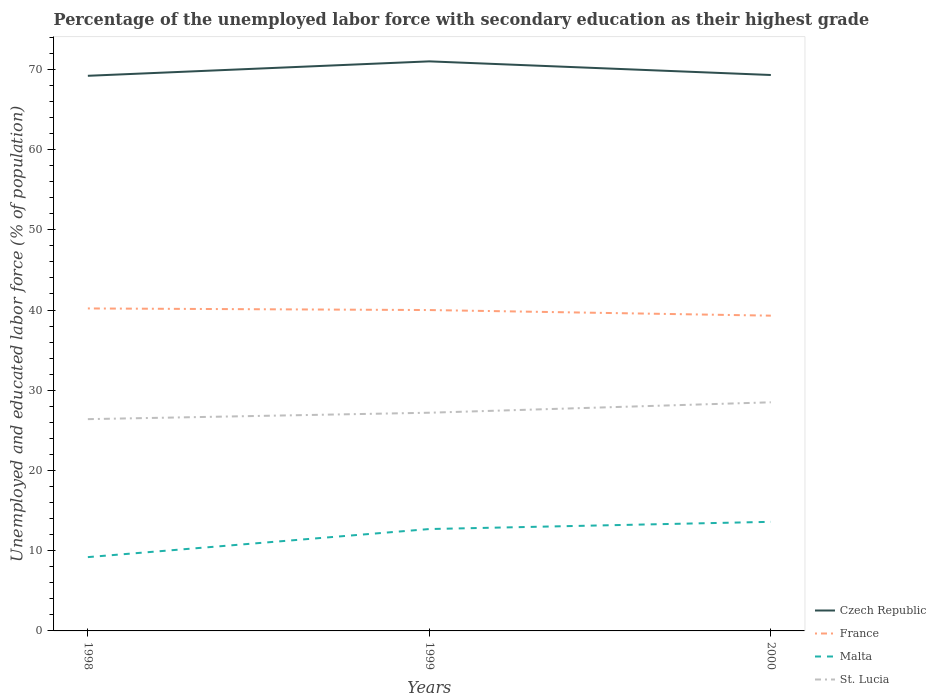Across all years, what is the maximum percentage of the unemployed labor force with secondary education in Czech Republic?
Your answer should be compact. 69.2. In which year was the percentage of the unemployed labor force with secondary education in Czech Republic maximum?
Give a very brief answer. 1998. What is the total percentage of the unemployed labor force with secondary education in Malta in the graph?
Make the answer very short. -0.9. What is the difference between the highest and the second highest percentage of the unemployed labor force with secondary education in France?
Offer a terse response. 0.9. What is the difference between two consecutive major ticks on the Y-axis?
Offer a terse response. 10. Are the values on the major ticks of Y-axis written in scientific E-notation?
Provide a succinct answer. No. Does the graph contain any zero values?
Ensure brevity in your answer.  No. How many legend labels are there?
Your response must be concise. 4. What is the title of the graph?
Provide a short and direct response. Percentage of the unemployed labor force with secondary education as their highest grade. What is the label or title of the X-axis?
Your answer should be very brief. Years. What is the label or title of the Y-axis?
Ensure brevity in your answer.  Unemployed and educated labor force (% of population). What is the Unemployed and educated labor force (% of population) in Czech Republic in 1998?
Make the answer very short. 69.2. What is the Unemployed and educated labor force (% of population) in France in 1998?
Provide a short and direct response. 40.2. What is the Unemployed and educated labor force (% of population) in Malta in 1998?
Keep it short and to the point. 9.2. What is the Unemployed and educated labor force (% of population) in St. Lucia in 1998?
Offer a very short reply. 26.4. What is the Unemployed and educated labor force (% of population) of Czech Republic in 1999?
Offer a terse response. 71. What is the Unemployed and educated labor force (% of population) of France in 1999?
Provide a short and direct response. 40. What is the Unemployed and educated labor force (% of population) of Malta in 1999?
Ensure brevity in your answer.  12.7. What is the Unemployed and educated labor force (% of population) of St. Lucia in 1999?
Ensure brevity in your answer.  27.2. What is the Unemployed and educated labor force (% of population) of Czech Republic in 2000?
Your answer should be very brief. 69.3. What is the Unemployed and educated labor force (% of population) of France in 2000?
Offer a very short reply. 39.3. What is the Unemployed and educated labor force (% of population) in Malta in 2000?
Your response must be concise. 13.6. What is the Unemployed and educated labor force (% of population) of St. Lucia in 2000?
Offer a very short reply. 28.5. Across all years, what is the maximum Unemployed and educated labor force (% of population) in Czech Republic?
Give a very brief answer. 71. Across all years, what is the maximum Unemployed and educated labor force (% of population) of France?
Offer a very short reply. 40.2. Across all years, what is the maximum Unemployed and educated labor force (% of population) of Malta?
Your response must be concise. 13.6. Across all years, what is the minimum Unemployed and educated labor force (% of population) of Czech Republic?
Offer a terse response. 69.2. Across all years, what is the minimum Unemployed and educated labor force (% of population) of France?
Ensure brevity in your answer.  39.3. Across all years, what is the minimum Unemployed and educated labor force (% of population) of Malta?
Offer a terse response. 9.2. Across all years, what is the minimum Unemployed and educated labor force (% of population) of St. Lucia?
Provide a short and direct response. 26.4. What is the total Unemployed and educated labor force (% of population) in Czech Republic in the graph?
Provide a succinct answer. 209.5. What is the total Unemployed and educated labor force (% of population) in France in the graph?
Provide a short and direct response. 119.5. What is the total Unemployed and educated labor force (% of population) in Malta in the graph?
Ensure brevity in your answer.  35.5. What is the total Unemployed and educated labor force (% of population) of St. Lucia in the graph?
Provide a short and direct response. 82.1. What is the difference between the Unemployed and educated labor force (% of population) in France in 1998 and that in 1999?
Give a very brief answer. 0.2. What is the difference between the Unemployed and educated labor force (% of population) of St. Lucia in 1998 and that in 1999?
Ensure brevity in your answer.  -0.8. What is the difference between the Unemployed and educated labor force (% of population) of France in 1999 and that in 2000?
Offer a very short reply. 0.7. What is the difference between the Unemployed and educated labor force (% of population) of Malta in 1999 and that in 2000?
Offer a very short reply. -0.9. What is the difference between the Unemployed and educated labor force (% of population) in Czech Republic in 1998 and the Unemployed and educated labor force (% of population) in France in 1999?
Offer a very short reply. 29.2. What is the difference between the Unemployed and educated labor force (% of population) of Czech Republic in 1998 and the Unemployed and educated labor force (% of population) of Malta in 1999?
Offer a terse response. 56.5. What is the difference between the Unemployed and educated labor force (% of population) of Czech Republic in 1998 and the Unemployed and educated labor force (% of population) of St. Lucia in 1999?
Your answer should be very brief. 42. What is the difference between the Unemployed and educated labor force (% of population) in France in 1998 and the Unemployed and educated labor force (% of population) in Malta in 1999?
Your answer should be compact. 27.5. What is the difference between the Unemployed and educated labor force (% of population) in Czech Republic in 1998 and the Unemployed and educated labor force (% of population) in France in 2000?
Offer a terse response. 29.9. What is the difference between the Unemployed and educated labor force (% of population) of Czech Republic in 1998 and the Unemployed and educated labor force (% of population) of Malta in 2000?
Your response must be concise. 55.6. What is the difference between the Unemployed and educated labor force (% of population) in Czech Republic in 1998 and the Unemployed and educated labor force (% of population) in St. Lucia in 2000?
Your answer should be compact. 40.7. What is the difference between the Unemployed and educated labor force (% of population) in France in 1998 and the Unemployed and educated labor force (% of population) in Malta in 2000?
Give a very brief answer. 26.6. What is the difference between the Unemployed and educated labor force (% of population) in Malta in 1998 and the Unemployed and educated labor force (% of population) in St. Lucia in 2000?
Ensure brevity in your answer.  -19.3. What is the difference between the Unemployed and educated labor force (% of population) in Czech Republic in 1999 and the Unemployed and educated labor force (% of population) in France in 2000?
Keep it short and to the point. 31.7. What is the difference between the Unemployed and educated labor force (% of population) of Czech Republic in 1999 and the Unemployed and educated labor force (% of population) of Malta in 2000?
Keep it short and to the point. 57.4. What is the difference between the Unemployed and educated labor force (% of population) of Czech Republic in 1999 and the Unemployed and educated labor force (% of population) of St. Lucia in 2000?
Your answer should be compact. 42.5. What is the difference between the Unemployed and educated labor force (% of population) of France in 1999 and the Unemployed and educated labor force (% of population) of Malta in 2000?
Keep it short and to the point. 26.4. What is the difference between the Unemployed and educated labor force (% of population) in Malta in 1999 and the Unemployed and educated labor force (% of population) in St. Lucia in 2000?
Provide a succinct answer. -15.8. What is the average Unemployed and educated labor force (% of population) in Czech Republic per year?
Provide a short and direct response. 69.83. What is the average Unemployed and educated labor force (% of population) in France per year?
Keep it short and to the point. 39.83. What is the average Unemployed and educated labor force (% of population) in Malta per year?
Offer a very short reply. 11.83. What is the average Unemployed and educated labor force (% of population) of St. Lucia per year?
Ensure brevity in your answer.  27.37. In the year 1998, what is the difference between the Unemployed and educated labor force (% of population) of Czech Republic and Unemployed and educated labor force (% of population) of St. Lucia?
Your answer should be compact. 42.8. In the year 1998, what is the difference between the Unemployed and educated labor force (% of population) of France and Unemployed and educated labor force (% of population) of Malta?
Ensure brevity in your answer.  31. In the year 1998, what is the difference between the Unemployed and educated labor force (% of population) of France and Unemployed and educated labor force (% of population) of St. Lucia?
Make the answer very short. 13.8. In the year 1998, what is the difference between the Unemployed and educated labor force (% of population) in Malta and Unemployed and educated labor force (% of population) in St. Lucia?
Keep it short and to the point. -17.2. In the year 1999, what is the difference between the Unemployed and educated labor force (% of population) in Czech Republic and Unemployed and educated labor force (% of population) in Malta?
Your answer should be very brief. 58.3. In the year 1999, what is the difference between the Unemployed and educated labor force (% of population) in Czech Republic and Unemployed and educated labor force (% of population) in St. Lucia?
Give a very brief answer. 43.8. In the year 1999, what is the difference between the Unemployed and educated labor force (% of population) in France and Unemployed and educated labor force (% of population) in Malta?
Provide a short and direct response. 27.3. In the year 2000, what is the difference between the Unemployed and educated labor force (% of population) in Czech Republic and Unemployed and educated labor force (% of population) in Malta?
Ensure brevity in your answer.  55.7. In the year 2000, what is the difference between the Unemployed and educated labor force (% of population) of Czech Republic and Unemployed and educated labor force (% of population) of St. Lucia?
Provide a succinct answer. 40.8. In the year 2000, what is the difference between the Unemployed and educated labor force (% of population) of France and Unemployed and educated labor force (% of population) of Malta?
Ensure brevity in your answer.  25.7. In the year 2000, what is the difference between the Unemployed and educated labor force (% of population) of France and Unemployed and educated labor force (% of population) of St. Lucia?
Your answer should be very brief. 10.8. In the year 2000, what is the difference between the Unemployed and educated labor force (% of population) in Malta and Unemployed and educated labor force (% of population) in St. Lucia?
Your answer should be very brief. -14.9. What is the ratio of the Unemployed and educated labor force (% of population) in Czech Republic in 1998 to that in 1999?
Keep it short and to the point. 0.97. What is the ratio of the Unemployed and educated labor force (% of population) in Malta in 1998 to that in 1999?
Make the answer very short. 0.72. What is the ratio of the Unemployed and educated labor force (% of population) of St. Lucia in 1998 to that in 1999?
Ensure brevity in your answer.  0.97. What is the ratio of the Unemployed and educated labor force (% of population) in France in 1998 to that in 2000?
Give a very brief answer. 1.02. What is the ratio of the Unemployed and educated labor force (% of population) of Malta in 1998 to that in 2000?
Your answer should be compact. 0.68. What is the ratio of the Unemployed and educated labor force (% of population) in St. Lucia in 1998 to that in 2000?
Provide a short and direct response. 0.93. What is the ratio of the Unemployed and educated labor force (% of population) of Czech Republic in 1999 to that in 2000?
Your answer should be very brief. 1.02. What is the ratio of the Unemployed and educated labor force (% of population) in France in 1999 to that in 2000?
Offer a terse response. 1.02. What is the ratio of the Unemployed and educated labor force (% of population) in Malta in 1999 to that in 2000?
Your response must be concise. 0.93. What is the ratio of the Unemployed and educated labor force (% of population) of St. Lucia in 1999 to that in 2000?
Keep it short and to the point. 0.95. What is the difference between the highest and the second highest Unemployed and educated labor force (% of population) of Czech Republic?
Offer a terse response. 1.7. What is the difference between the highest and the second highest Unemployed and educated labor force (% of population) of France?
Keep it short and to the point. 0.2. What is the difference between the highest and the second highest Unemployed and educated labor force (% of population) in Malta?
Give a very brief answer. 0.9. What is the difference between the highest and the second highest Unemployed and educated labor force (% of population) of St. Lucia?
Ensure brevity in your answer.  1.3. What is the difference between the highest and the lowest Unemployed and educated labor force (% of population) in Czech Republic?
Ensure brevity in your answer.  1.8. 